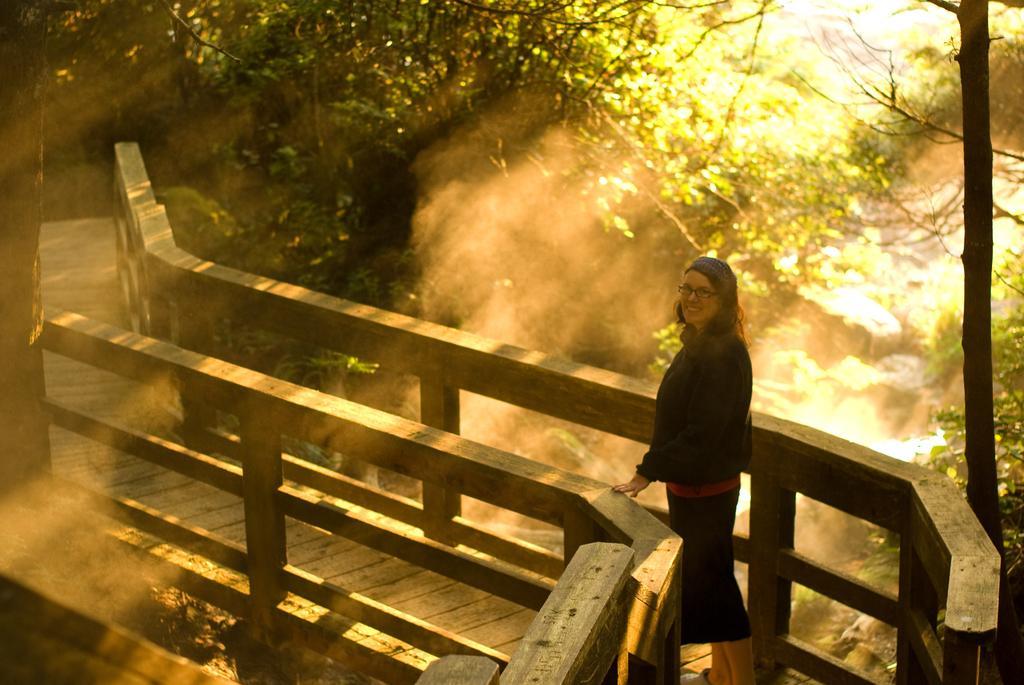How would you summarize this image in a sentence or two? In this image I can see a woman wearing black color dress is standing on a wooden bridge. I can see the wooden railing, few trees and few rocks in the background. 